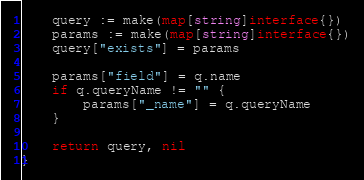Convert code to text. <code><loc_0><loc_0><loc_500><loc_500><_Go_>	query := make(map[string]interface{})
	params := make(map[string]interface{})
	query["exists"] = params

	params["field"] = q.name
	if q.queryName != "" {
		params["_name"] = q.queryName
	}

	return query, nil
}
</code> 